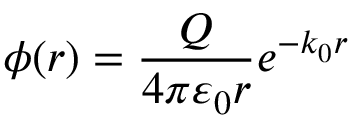<formula> <loc_0><loc_0><loc_500><loc_500>\phi ( r ) = { \frac { Q } { 4 \pi \varepsilon _ { 0 } r } } e ^ { - k _ { 0 } r }</formula> 